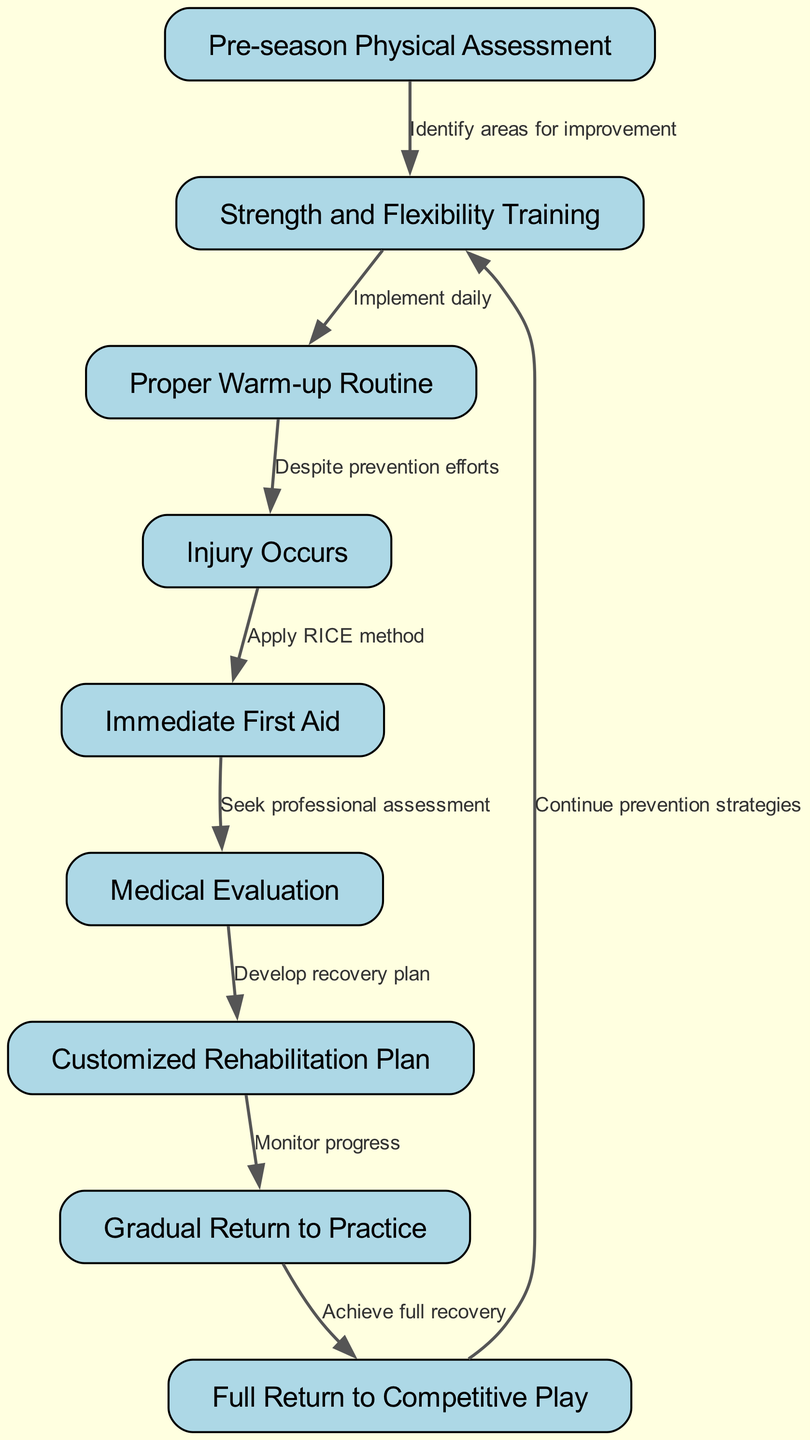What is the first step in the pathway? The first node in the pathway is "Pre-season Physical Assessment," which signifies the initial assessment players undergo before the season begins.
Answer: Pre-season Physical Assessment How many nodes are in the diagram? By counting the individual elements labeled in the diagram, there are a total of nine nodes present.
Answer: 9 What method should be applied immediately after an injury occurs? The edge from "Injury Occurs" to "Immediate First Aid" suggests that the RICE method should be applied for first aid.
Answer: RICE method What is the purpose of "Strength and Flexibility Training"? This node directly follows "Pre-season Physical Assessment," indicating that its purpose is to identify areas for improvement in young athletes.
Answer: Identify areas for improvement Which action follows medical evaluation? The edge from "Medical Evaluation" to "Customized Rehabilitation Plan" shows that the next action after evaluation is to develop a tailored rehabilitation plan for recovery.
Answer: Customized Rehabilitation Plan What does "Gradual Return to Practice" monitor? The pathway indicates a connection from "Customized Rehabilitation Plan" to "Gradual Return to Practice," emphasizing the importance of monitoring progress throughout recovery.
Answer: Monitor progress After a full return to competitive play, what should be continued? The last edge in the diagram indicates that "Continue prevention strategies" should be adopted to minimize the risk of future injuries.
Answer: Continue prevention strategies What is the connection between "Proper Warm-up Routine" and "Injury Occurs"? The edge shows that even with a "Proper Warm-up Routine" implemented daily, injuries can still occur despite these prevention efforts.
Answer: Despite prevention efforts What step comes after applying immediate first aid? Following "Immediate First Aid," the next step is to "Seek professional assessment" indicated in the pathway.
Answer: Seek professional assessment 